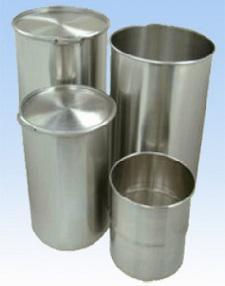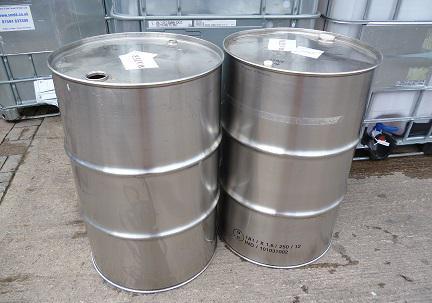The first image is the image on the left, the second image is the image on the right. Analyze the images presented: Is the assertion "All barrels are gray steel and some barrels have open tops." valid? Answer yes or no. Yes. The first image is the image on the left, the second image is the image on the right. Examine the images to the left and right. Is the description "There are more silver barrels in the image on the left than on the right." accurate? Answer yes or no. Yes. 